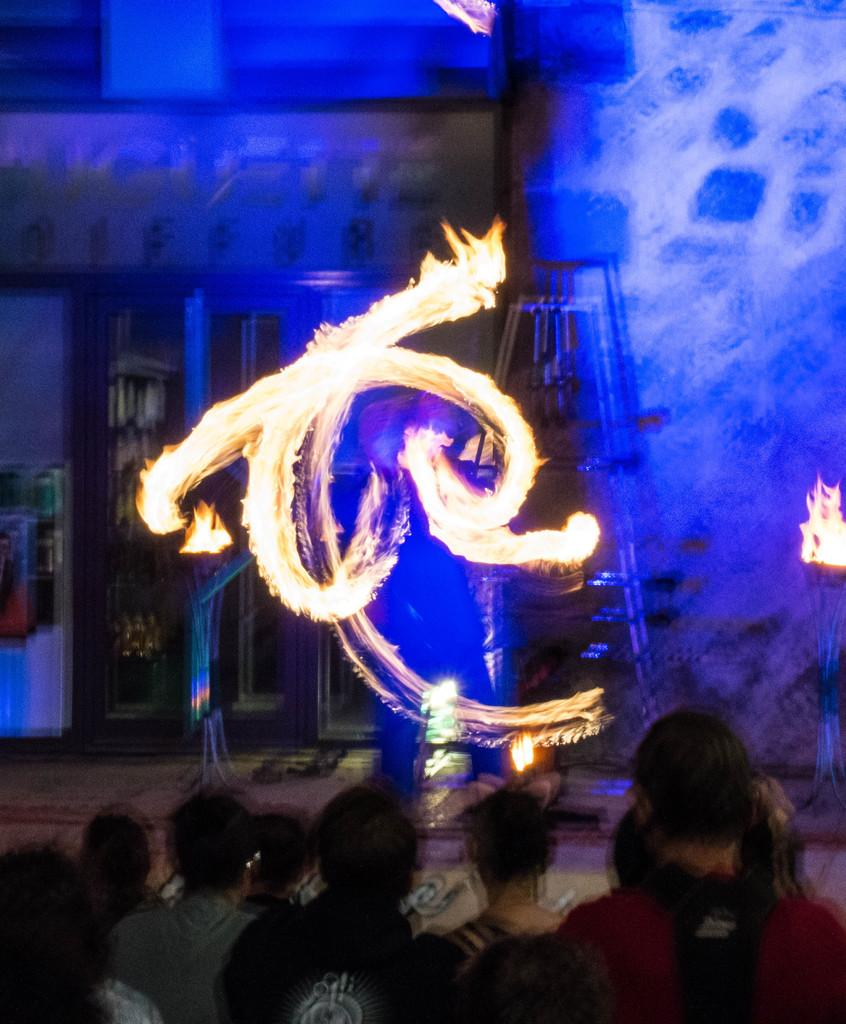What is happening in the image? There are people standing in the image. What can be seen in the background of the image? There is fire visible in the background of the image, along with other objects. What type of prose is being recited by the people in the image? There is no indication in the image that the people are reciting any prose. What kind of soup is being served in the image? There is no soup present in the image. 